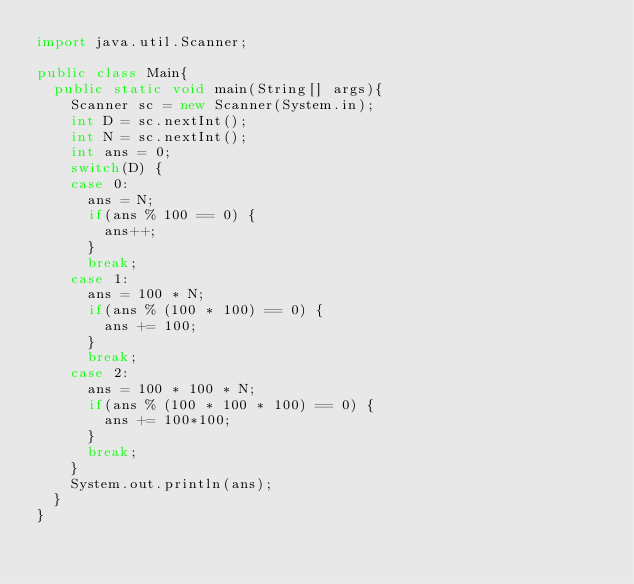Convert code to text. <code><loc_0><loc_0><loc_500><loc_500><_Java_>import java.util.Scanner;

public class Main{
	public static void main(String[] args){
		Scanner sc = new Scanner(System.in);
		int D = sc.nextInt();
		int N = sc.nextInt();
		int ans = 0;
		switch(D) {
		case 0:
			ans = N;
			if(ans % 100 == 0) {
				ans++;
			}
			break;
		case 1:
			ans = 100 * N;
			if(ans % (100 * 100) == 0) {
				ans += 100;
			}
			break;
		case 2:
			ans = 100 * 100 * N;
			if(ans % (100 * 100 * 100) == 0) {
				ans += 100*100;
			}
			break;
		}
		System.out.println(ans);
	}
}</code> 